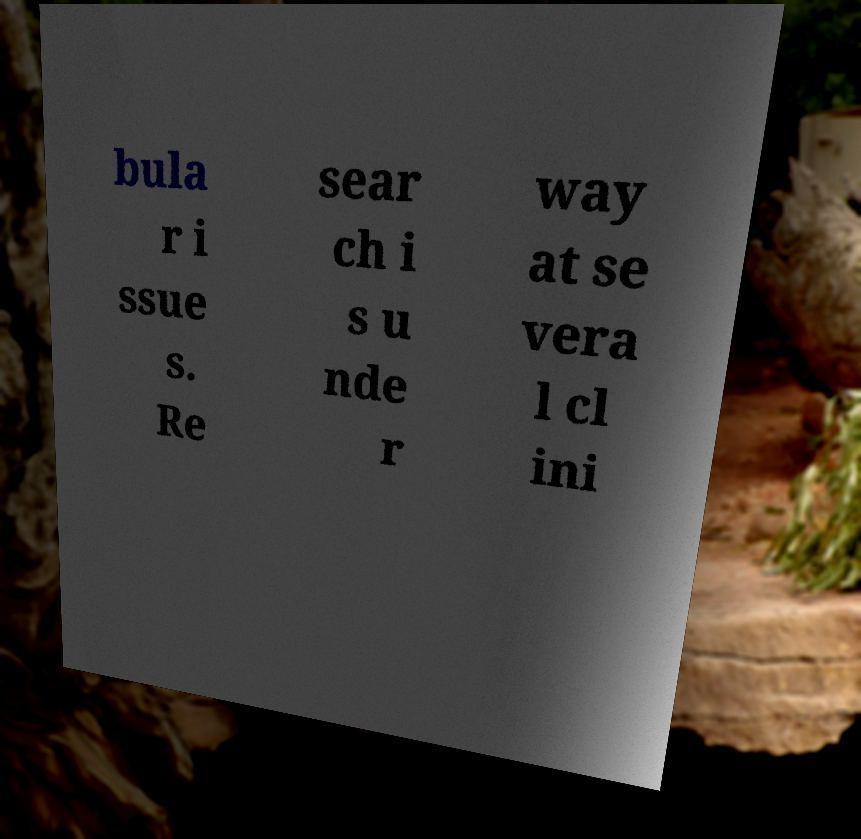I need the written content from this picture converted into text. Can you do that? bula r i ssue s. Re sear ch i s u nde r way at se vera l cl ini 